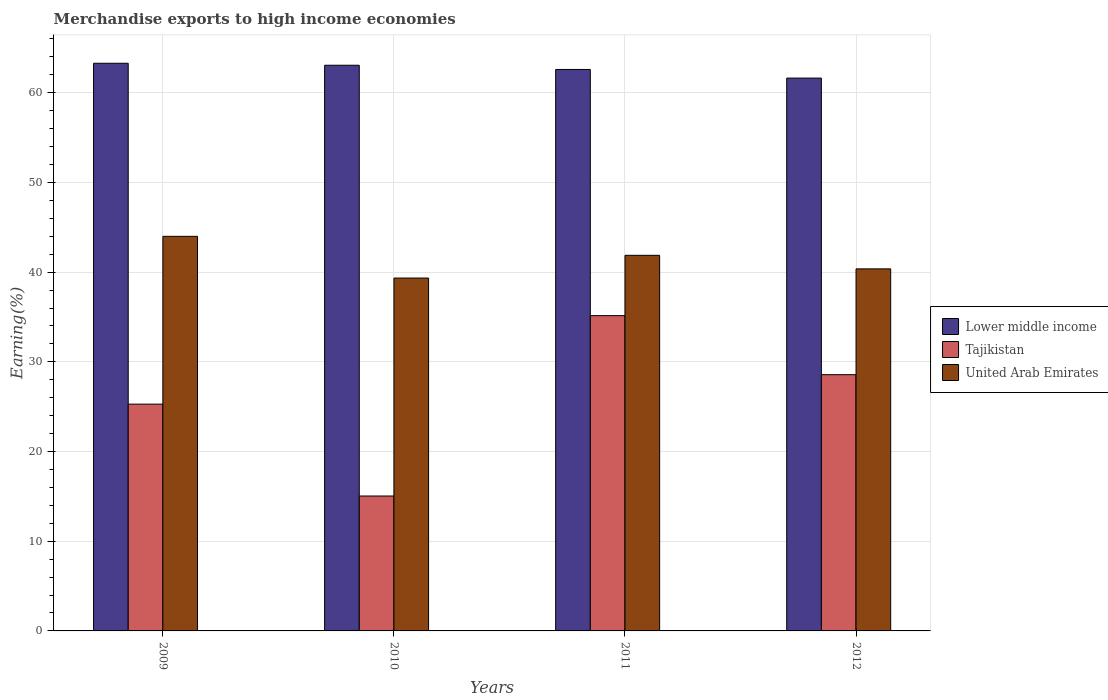How many groups of bars are there?
Provide a short and direct response. 4. Are the number of bars per tick equal to the number of legend labels?
Offer a very short reply. Yes. Are the number of bars on each tick of the X-axis equal?
Your response must be concise. Yes. How many bars are there on the 1st tick from the left?
Your answer should be very brief. 3. How many bars are there on the 3rd tick from the right?
Keep it short and to the point. 3. In how many cases, is the number of bars for a given year not equal to the number of legend labels?
Offer a terse response. 0. What is the percentage of amount earned from merchandise exports in Tajikistan in 2010?
Keep it short and to the point. 15.04. Across all years, what is the maximum percentage of amount earned from merchandise exports in Lower middle income?
Your response must be concise. 63.29. Across all years, what is the minimum percentage of amount earned from merchandise exports in United Arab Emirates?
Give a very brief answer. 39.34. In which year was the percentage of amount earned from merchandise exports in Lower middle income minimum?
Your answer should be very brief. 2012. What is the total percentage of amount earned from merchandise exports in Lower middle income in the graph?
Your response must be concise. 250.59. What is the difference between the percentage of amount earned from merchandise exports in United Arab Emirates in 2010 and that in 2011?
Keep it short and to the point. -2.53. What is the difference between the percentage of amount earned from merchandise exports in United Arab Emirates in 2011 and the percentage of amount earned from merchandise exports in Tajikistan in 2012?
Keep it short and to the point. 13.31. What is the average percentage of amount earned from merchandise exports in Lower middle income per year?
Your response must be concise. 62.65. In the year 2012, what is the difference between the percentage of amount earned from merchandise exports in Tajikistan and percentage of amount earned from merchandise exports in United Arab Emirates?
Your answer should be very brief. -11.8. What is the ratio of the percentage of amount earned from merchandise exports in Lower middle income in 2009 to that in 2011?
Make the answer very short. 1.01. Is the percentage of amount earned from merchandise exports in Lower middle income in 2009 less than that in 2010?
Keep it short and to the point. No. Is the difference between the percentage of amount earned from merchandise exports in Tajikistan in 2011 and 2012 greater than the difference between the percentage of amount earned from merchandise exports in United Arab Emirates in 2011 and 2012?
Provide a short and direct response. Yes. What is the difference between the highest and the second highest percentage of amount earned from merchandise exports in Lower middle income?
Keep it short and to the point. 0.22. What is the difference between the highest and the lowest percentage of amount earned from merchandise exports in Lower middle income?
Provide a short and direct response. 1.65. In how many years, is the percentage of amount earned from merchandise exports in Lower middle income greater than the average percentage of amount earned from merchandise exports in Lower middle income taken over all years?
Make the answer very short. 2. What does the 1st bar from the left in 2012 represents?
Offer a terse response. Lower middle income. What does the 3rd bar from the right in 2012 represents?
Your answer should be very brief. Lower middle income. Is it the case that in every year, the sum of the percentage of amount earned from merchandise exports in Tajikistan and percentage of amount earned from merchandise exports in United Arab Emirates is greater than the percentage of amount earned from merchandise exports in Lower middle income?
Your answer should be very brief. No. Are all the bars in the graph horizontal?
Make the answer very short. No. Are the values on the major ticks of Y-axis written in scientific E-notation?
Provide a succinct answer. No. Does the graph contain any zero values?
Make the answer very short. No. Does the graph contain grids?
Give a very brief answer. Yes. Where does the legend appear in the graph?
Keep it short and to the point. Center right. How many legend labels are there?
Offer a terse response. 3. What is the title of the graph?
Your answer should be compact. Merchandise exports to high income economies. What is the label or title of the X-axis?
Your answer should be compact. Years. What is the label or title of the Y-axis?
Your answer should be compact. Earning(%). What is the Earning(%) in Lower middle income in 2009?
Your answer should be very brief. 63.29. What is the Earning(%) in Tajikistan in 2009?
Offer a terse response. 25.28. What is the Earning(%) of United Arab Emirates in 2009?
Offer a terse response. 43.99. What is the Earning(%) of Lower middle income in 2010?
Offer a very short reply. 63.07. What is the Earning(%) of Tajikistan in 2010?
Offer a very short reply. 15.04. What is the Earning(%) in United Arab Emirates in 2010?
Make the answer very short. 39.34. What is the Earning(%) in Lower middle income in 2011?
Your response must be concise. 62.6. What is the Earning(%) of Tajikistan in 2011?
Ensure brevity in your answer.  35.15. What is the Earning(%) in United Arab Emirates in 2011?
Provide a short and direct response. 41.88. What is the Earning(%) in Lower middle income in 2012?
Keep it short and to the point. 61.64. What is the Earning(%) of Tajikistan in 2012?
Your answer should be very brief. 28.57. What is the Earning(%) in United Arab Emirates in 2012?
Your answer should be very brief. 40.37. Across all years, what is the maximum Earning(%) in Lower middle income?
Your response must be concise. 63.29. Across all years, what is the maximum Earning(%) in Tajikistan?
Your response must be concise. 35.15. Across all years, what is the maximum Earning(%) of United Arab Emirates?
Give a very brief answer. 43.99. Across all years, what is the minimum Earning(%) of Lower middle income?
Your answer should be very brief. 61.64. Across all years, what is the minimum Earning(%) of Tajikistan?
Give a very brief answer. 15.04. Across all years, what is the minimum Earning(%) of United Arab Emirates?
Ensure brevity in your answer.  39.34. What is the total Earning(%) in Lower middle income in the graph?
Offer a very short reply. 250.59. What is the total Earning(%) of Tajikistan in the graph?
Make the answer very short. 104.05. What is the total Earning(%) of United Arab Emirates in the graph?
Keep it short and to the point. 165.58. What is the difference between the Earning(%) of Lower middle income in 2009 and that in 2010?
Make the answer very short. 0.22. What is the difference between the Earning(%) of Tajikistan in 2009 and that in 2010?
Your response must be concise. 10.24. What is the difference between the Earning(%) of United Arab Emirates in 2009 and that in 2010?
Provide a succinct answer. 4.65. What is the difference between the Earning(%) of Lower middle income in 2009 and that in 2011?
Make the answer very short. 0.69. What is the difference between the Earning(%) of Tajikistan in 2009 and that in 2011?
Offer a terse response. -9.87. What is the difference between the Earning(%) in United Arab Emirates in 2009 and that in 2011?
Your answer should be very brief. 2.12. What is the difference between the Earning(%) of Lower middle income in 2009 and that in 2012?
Provide a succinct answer. 1.65. What is the difference between the Earning(%) of Tajikistan in 2009 and that in 2012?
Offer a terse response. -3.28. What is the difference between the Earning(%) in United Arab Emirates in 2009 and that in 2012?
Your response must be concise. 3.63. What is the difference between the Earning(%) in Lower middle income in 2010 and that in 2011?
Your answer should be very brief. 0.47. What is the difference between the Earning(%) of Tajikistan in 2010 and that in 2011?
Offer a very short reply. -20.11. What is the difference between the Earning(%) in United Arab Emirates in 2010 and that in 2011?
Give a very brief answer. -2.53. What is the difference between the Earning(%) of Lower middle income in 2010 and that in 2012?
Give a very brief answer. 1.43. What is the difference between the Earning(%) of Tajikistan in 2010 and that in 2012?
Keep it short and to the point. -13.53. What is the difference between the Earning(%) in United Arab Emirates in 2010 and that in 2012?
Keep it short and to the point. -1.02. What is the difference between the Earning(%) in Lower middle income in 2011 and that in 2012?
Your response must be concise. 0.96. What is the difference between the Earning(%) of Tajikistan in 2011 and that in 2012?
Keep it short and to the point. 6.58. What is the difference between the Earning(%) in United Arab Emirates in 2011 and that in 2012?
Offer a terse response. 1.51. What is the difference between the Earning(%) of Lower middle income in 2009 and the Earning(%) of Tajikistan in 2010?
Offer a very short reply. 48.25. What is the difference between the Earning(%) in Lower middle income in 2009 and the Earning(%) in United Arab Emirates in 2010?
Your answer should be very brief. 23.95. What is the difference between the Earning(%) of Tajikistan in 2009 and the Earning(%) of United Arab Emirates in 2010?
Give a very brief answer. -14.06. What is the difference between the Earning(%) of Lower middle income in 2009 and the Earning(%) of Tajikistan in 2011?
Provide a succinct answer. 28.14. What is the difference between the Earning(%) of Lower middle income in 2009 and the Earning(%) of United Arab Emirates in 2011?
Ensure brevity in your answer.  21.41. What is the difference between the Earning(%) in Tajikistan in 2009 and the Earning(%) in United Arab Emirates in 2011?
Give a very brief answer. -16.59. What is the difference between the Earning(%) in Lower middle income in 2009 and the Earning(%) in Tajikistan in 2012?
Give a very brief answer. 34.72. What is the difference between the Earning(%) in Lower middle income in 2009 and the Earning(%) in United Arab Emirates in 2012?
Provide a short and direct response. 22.92. What is the difference between the Earning(%) in Tajikistan in 2009 and the Earning(%) in United Arab Emirates in 2012?
Ensure brevity in your answer.  -15.08. What is the difference between the Earning(%) of Lower middle income in 2010 and the Earning(%) of Tajikistan in 2011?
Keep it short and to the point. 27.92. What is the difference between the Earning(%) of Lower middle income in 2010 and the Earning(%) of United Arab Emirates in 2011?
Offer a terse response. 21.19. What is the difference between the Earning(%) in Tajikistan in 2010 and the Earning(%) in United Arab Emirates in 2011?
Provide a short and direct response. -26.84. What is the difference between the Earning(%) of Lower middle income in 2010 and the Earning(%) of Tajikistan in 2012?
Make the answer very short. 34.5. What is the difference between the Earning(%) in Lower middle income in 2010 and the Earning(%) in United Arab Emirates in 2012?
Offer a terse response. 22.7. What is the difference between the Earning(%) in Tajikistan in 2010 and the Earning(%) in United Arab Emirates in 2012?
Offer a very short reply. -25.32. What is the difference between the Earning(%) of Lower middle income in 2011 and the Earning(%) of Tajikistan in 2012?
Ensure brevity in your answer.  34.03. What is the difference between the Earning(%) of Lower middle income in 2011 and the Earning(%) of United Arab Emirates in 2012?
Offer a terse response. 22.23. What is the difference between the Earning(%) of Tajikistan in 2011 and the Earning(%) of United Arab Emirates in 2012?
Your answer should be compact. -5.21. What is the average Earning(%) in Lower middle income per year?
Provide a short and direct response. 62.65. What is the average Earning(%) in Tajikistan per year?
Your answer should be compact. 26.01. What is the average Earning(%) of United Arab Emirates per year?
Give a very brief answer. 41.39. In the year 2009, what is the difference between the Earning(%) of Lower middle income and Earning(%) of Tajikistan?
Your response must be concise. 38. In the year 2009, what is the difference between the Earning(%) of Lower middle income and Earning(%) of United Arab Emirates?
Offer a terse response. 19.3. In the year 2009, what is the difference between the Earning(%) of Tajikistan and Earning(%) of United Arab Emirates?
Ensure brevity in your answer.  -18.71. In the year 2010, what is the difference between the Earning(%) of Lower middle income and Earning(%) of Tajikistan?
Ensure brevity in your answer.  48.03. In the year 2010, what is the difference between the Earning(%) in Lower middle income and Earning(%) in United Arab Emirates?
Give a very brief answer. 23.73. In the year 2010, what is the difference between the Earning(%) in Tajikistan and Earning(%) in United Arab Emirates?
Give a very brief answer. -24.3. In the year 2011, what is the difference between the Earning(%) in Lower middle income and Earning(%) in Tajikistan?
Ensure brevity in your answer.  27.45. In the year 2011, what is the difference between the Earning(%) of Lower middle income and Earning(%) of United Arab Emirates?
Offer a terse response. 20.72. In the year 2011, what is the difference between the Earning(%) in Tajikistan and Earning(%) in United Arab Emirates?
Make the answer very short. -6.72. In the year 2012, what is the difference between the Earning(%) in Lower middle income and Earning(%) in Tajikistan?
Your answer should be compact. 33.07. In the year 2012, what is the difference between the Earning(%) of Lower middle income and Earning(%) of United Arab Emirates?
Give a very brief answer. 21.27. In the year 2012, what is the difference between the Earning(%) of Tajikistan and Earning(%) of United Arab Emirates?
Give a very brief answer. -11.8. What is the ratio of the Earning(%) in Lower middle income in 2009 to that in 2010?
Your response must be concise. 1. What is the ratio of the Earning(%) of Tajikistan in 2009 to that in 2010?
Offer a very short reply. 1.68. What is the ratio of the Earning(%) in United Arab Emirates in 2009 to that in 2010?
Offer a terse response. 1.12. What is the ratio of the Earning(%) of Lower middle income in 2009 to that in 2011?
Provide a short and direct response. 1.01. What is the ratio of the Earning(%) in Tajikistan in 2009 to that in 2011?
Offer a terse response. 0.72. What is the ratio of the Earning(%) in United Arab Emirates in 2009 to that in 2011?
Offer a very short reply. 1.05. What is the ratio of the Earning(%) in Lower middle income in 2009 to that in 2012?
Offer a very short reply. 1.03. What is the ratio of the Earning(%) of Tajikistan in 2009 to that in 2012?
Your answer should be very brief. 0.89. What is the ratio of the Earning(%) of United Arab Emirates in 2009 to that in 2012?
Provide a short and direct response. 1.09. What is the ratio of the Earning(%) of Lower middle income in 2010 to that in 2011?
Provide a succinct answer. 1.01. What is the ratio of the Earning(%) in Tajikistan in 2010 to that in 2011?
Your response must be concise. 0.43. What is the ratio of the Earning(%) in United Arab Emirates in 2010 to that in 2011?
Your answer should be compact. 0.94. What is the ratio of the Earning(%) in Lower middle income in 2010 to that in 2012?
Ensure brevity in your answer.  1.02. What is the ratio of the Earning(%) in Tajikistan in 2010 to that in 2012?
Keep it short and to the point. 0.53. What is the ratio of the Earning(%) in United Arab Emirates in 2010 to that in 2012?
Provide a short and direct response. 0.97. What is the ratio of the Earning(%) of Lower middle income in 2011 to that in 2012?
Keep it short and to the point. 1.02. What is the ratio of the Earning(%) in Tajikistan in 2011 to that in 2012?
Your answer should be very brief. 1.23. What is the ratio of the Earning(%) of United Arab Emirates in 2011 to that in 2012?
Make the answer very short. 1.04. What is the difference between the highest and the second highest Earning(%) of Lower middle income?
Your response must be concise. 0.22. What is the difference between the highest and the second highest Earning(%) of Tajikistan?
Give a very brief answer. 6.58. What is the difference between the highest and the second highest Earning(%) in United Arab Emirates?
Provide a succinct answer. 2.12. What is the difference between the highest and the lowest Earning(%) in Lower middle income?
Give a very brief answer. 1.65. What is the difference between the highest and the lowest Earning(%) of Tajikistan?
Your answer should be very brief. 20.11. What is the difference between the highest and the lowest Earning(%) of United Arab Emirates?
Offer a terse response. 4.65. 